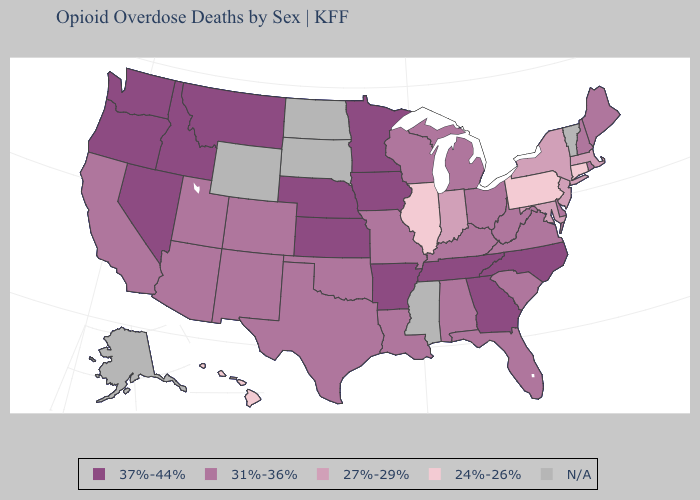What is the highest value in the USA?
Short answer required. 37%-44%. Which states have the highest value in the USA?
Short answer required. Arkansas, Georgia, Idaho, Iowa, Kansas, Minnesota, Montana, Nebraska, Nevada, North Carolina, Oregon, Tennessee, Washington. What is the highest value in the USA?
Write a very short answer. 37%-44%. Among the states that border Colorado , does Kansas have the highest value?
Keep it brief. Yes. What is the lowest value in the South?
Write a very short answer. 27%-29%. What is the value of Idaho?
Quick response, please. 37%-44%. What is the highest value in the South ?
Answer briefly. 37%-44%. Which states have the highest value in the USA?
Write a very short answer. Arkansas, Georgia, Idaho, Iowa, Kansas, Minnesota, Montana, Nebraska, Nevada, North Carolina, Oregon, Tennessee, Washington. Among the states that border Georgia , which have the highest value?
Quick response, please. North Carolina, Tennessee. How many symbols are there in the legend?
Write a very short answer. 5. What is the highest value in the USA?
Be succinct. 37%-44%. Does Hawaii have the lowest value in the West?
Concise answer only. Yes. Which states have the lowest value in the South?
Be succinct. Maryland. Name the states that have a value in the range 24%-26%?
Concise answer only. Connecticut, Hawaii, Illinois, Pennsylvania. 